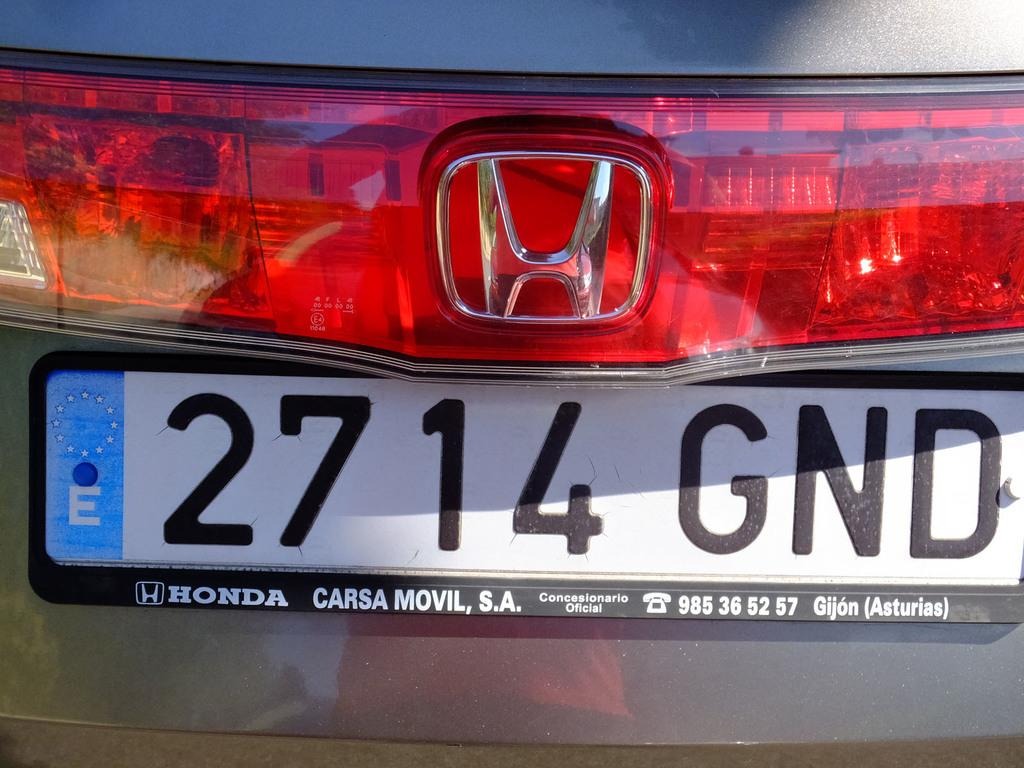<image>
Offer a succinct explanation of the picture presented. the numbers 2714 that are on the back of a license plate 